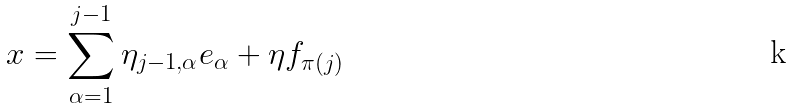Convert formula to latex. <formula><loc_0><loc_0><loc_500><loc_500>x = \sum _ { \alpha = 1 } ^ { j - 1 } \eta _ { j - 1 , \alpha } e _ { \alpha } + \eta f _ { \pi ( j ) }</formula> 